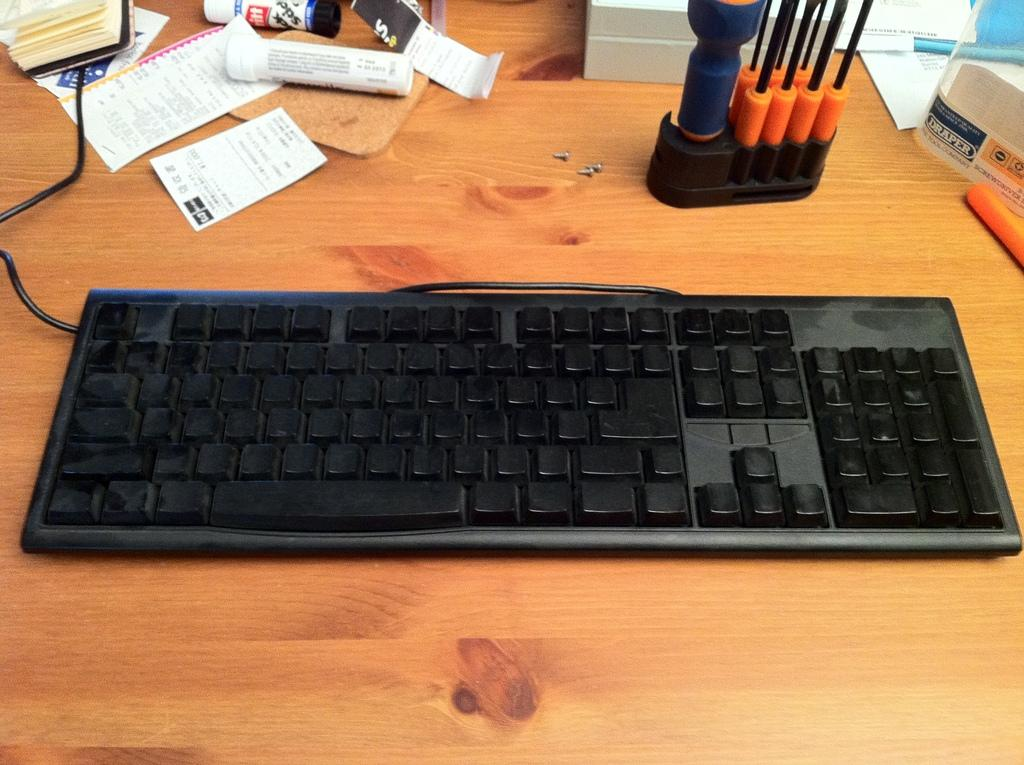<image>
Write a terse but informative summary of the picture. Next to some small screwdrivers is an item with the word Draper on it. 